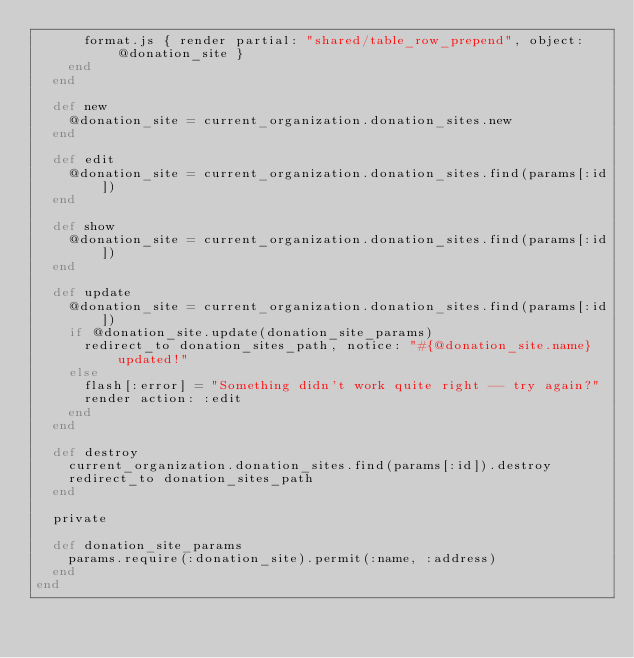Convert code to text. <code><loc_0><loc_0><loc_500><loc_500><_Ruby_>      format.js { render partial: "shared/table_row_prepend", object: @donation_site }
    end
  end

  def new
    @donation_site = current_organization.donation_sites.new
  end

  def edit
    @donation_site = current_organization.donation_sites.find(params[:id])
  end

  def show
    @donation_site = current_organization.donation_sites.find(params[:id])
  end

  def update
    @donation_site = current_organization.donation_sites.find(params[:id])
    if @donation_site.update(donation_site_params)
      redirect_to donation_sites_path, notice: "#{@donation_site.name} updated!"
    else
      flash[:error] = "Something didn't work quite right -- try again?"
      render action: :edit
    end
  end

  def destroy
    current_organization.donation_sites.find(params[:id]).destroy
    redirect_to donation_sites_path
  end

  private

  def donation_site_params
    params.require(:donation_site).permit(:name, :address)
  end
end
</code> 